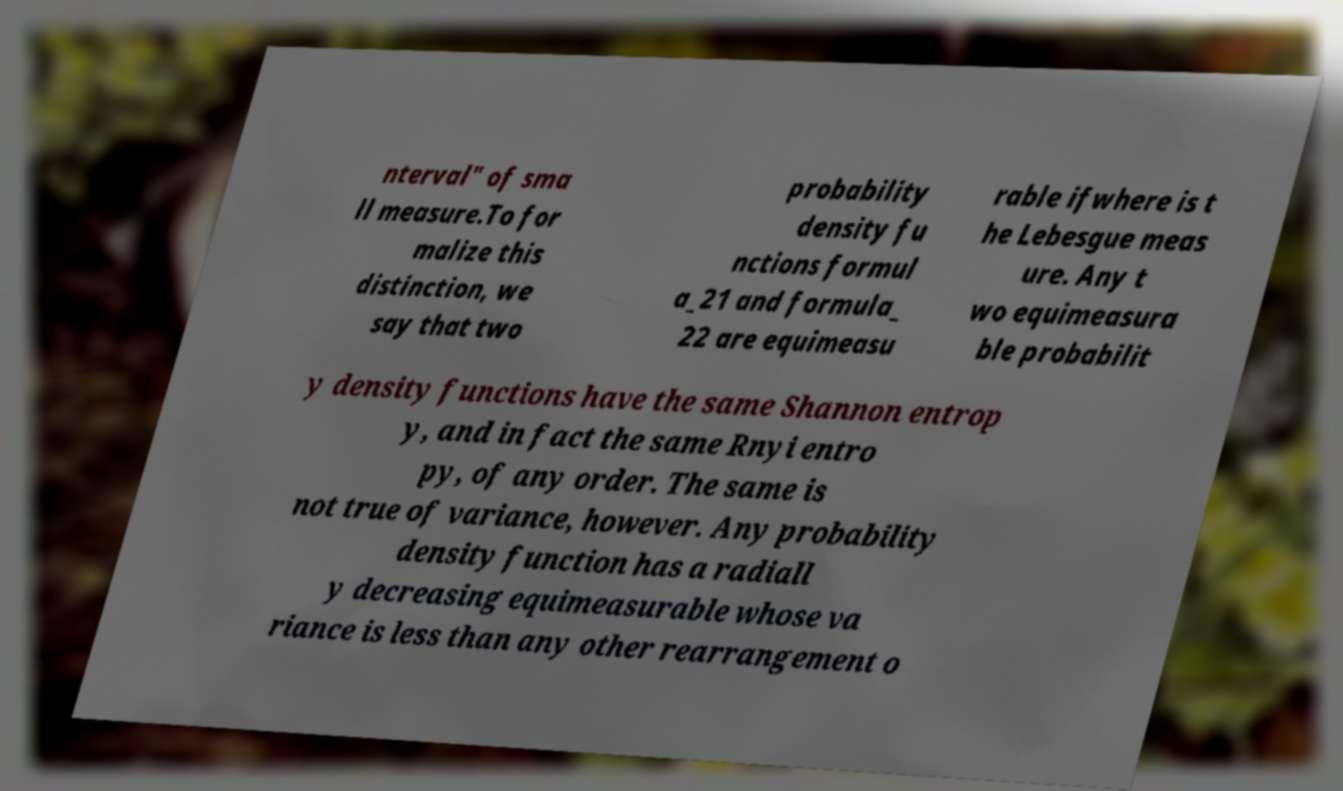There's text embedded in this image that I need extracted. Can you transcribe it verbatim? nterval" of sma ll measure.To for malize this distinction, we say that two probability density fu nctions formul a_21 and formula_ 22 are equimeasu rable ifwhere is t he Lebesgue meas ure. Any t wo equimeasura ble probabilit y density functions have the same Shannon entrop y, and in fact the same Rnyi entro py, of any order. The same is not true of variance, however. Any probability density function has a radiall y decreasing equimeasurable whose va riance is less than any other rearrangement o 